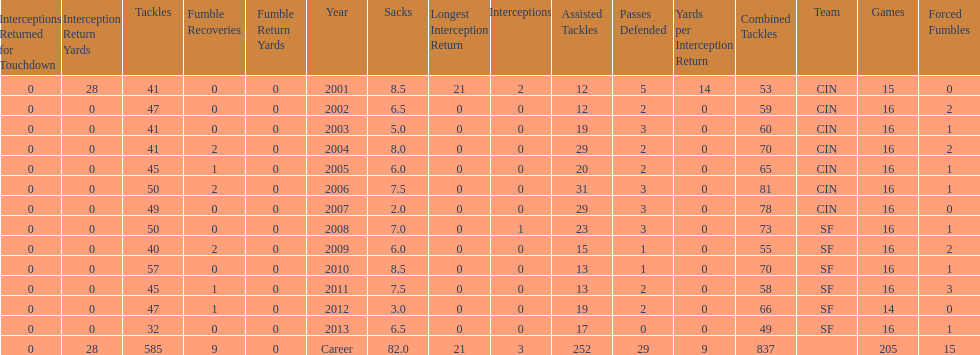How many sacks did this player have in his first five seasons? 34. 